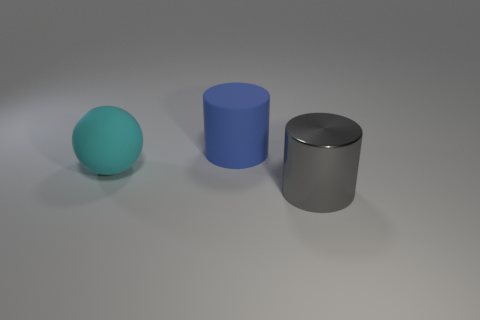Are there fewer cylinders than large rubber balls?
Give a very brief answer. No. Do the cyan rubber object and the thing behind the rubber ball have the same shape?
Make the answer very short. No. There is a thing that is right of the rubber sphere and behind the metal cylinder; what is its shape?
Offer a terse response. Cylinder. Are there an equal number of large blue cylinders behind the blue matte cylinder and big cyan rubber balls that are to the right of the cyan rubber thing?
Your answer should be compact. Yes. Do the matte object on the right side of the matte sphere and the gray thing have the same shape?
Provide a short and direct response. Yes. How many blue things are either shiny cylinders or matte cylinders?
Offer a terse response. 1. What is the material of the blue thing that is the same shape as the gray object?
Provide a short and direct response. Rubber. There is a large matte thing left of the blue matte object; what is its shape?
Keep it short and to the point. Sphere. Is there another cyan object that has the same material as the large cyan object?
Make the answer very short. No. Do the blue cylinder and the sphere have the same size?
Give a very brief answer. Yes. 